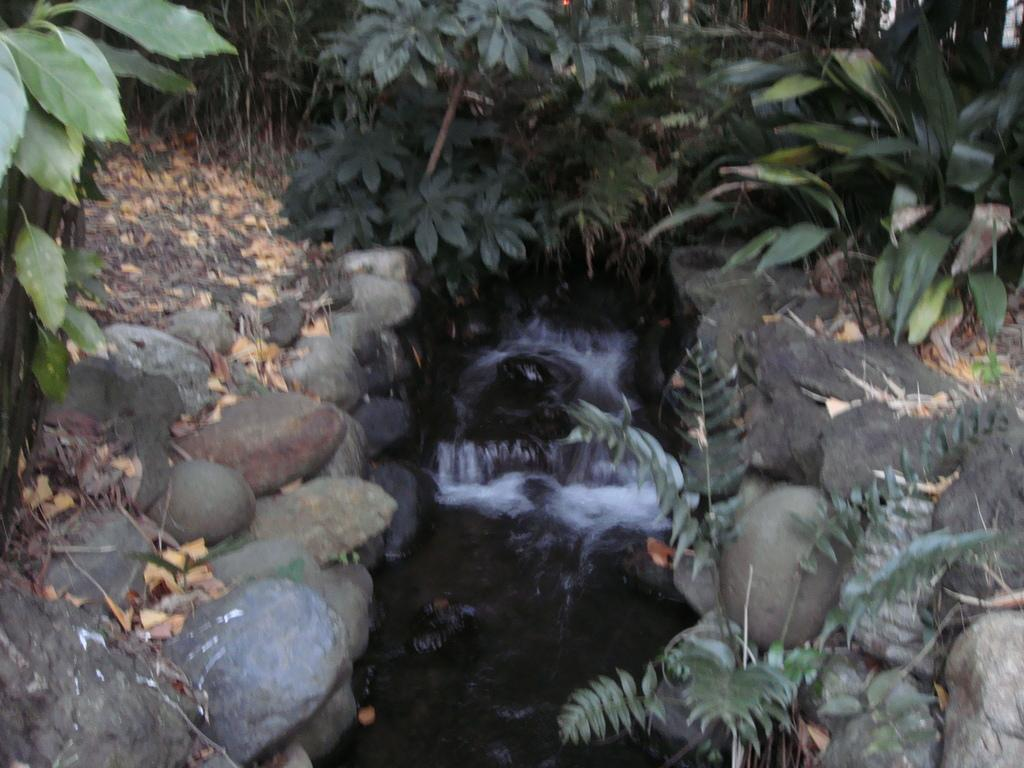What is the main feature in the middle of the image? There is water flowing in the middle of the image. What can be seen on either side of the water? There are stones on either side of the water. What type of vegetation is visible in the image? There are trees visible at the back side of the image. What is the size of the root visible in the image? There is no root visible in the image; it features water flowing between stones with trees in the background. 